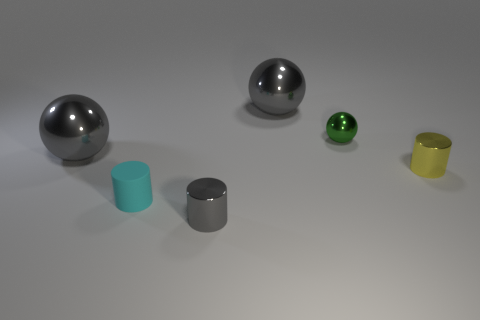What material is the cyan object that is the same size as the yellow object? The cyan object which appears to be the same size as the yellow object is likely made of plastic. It has a matte finish and a slightly reflective surface which is consistent with plastic materials used in everyday objects. 